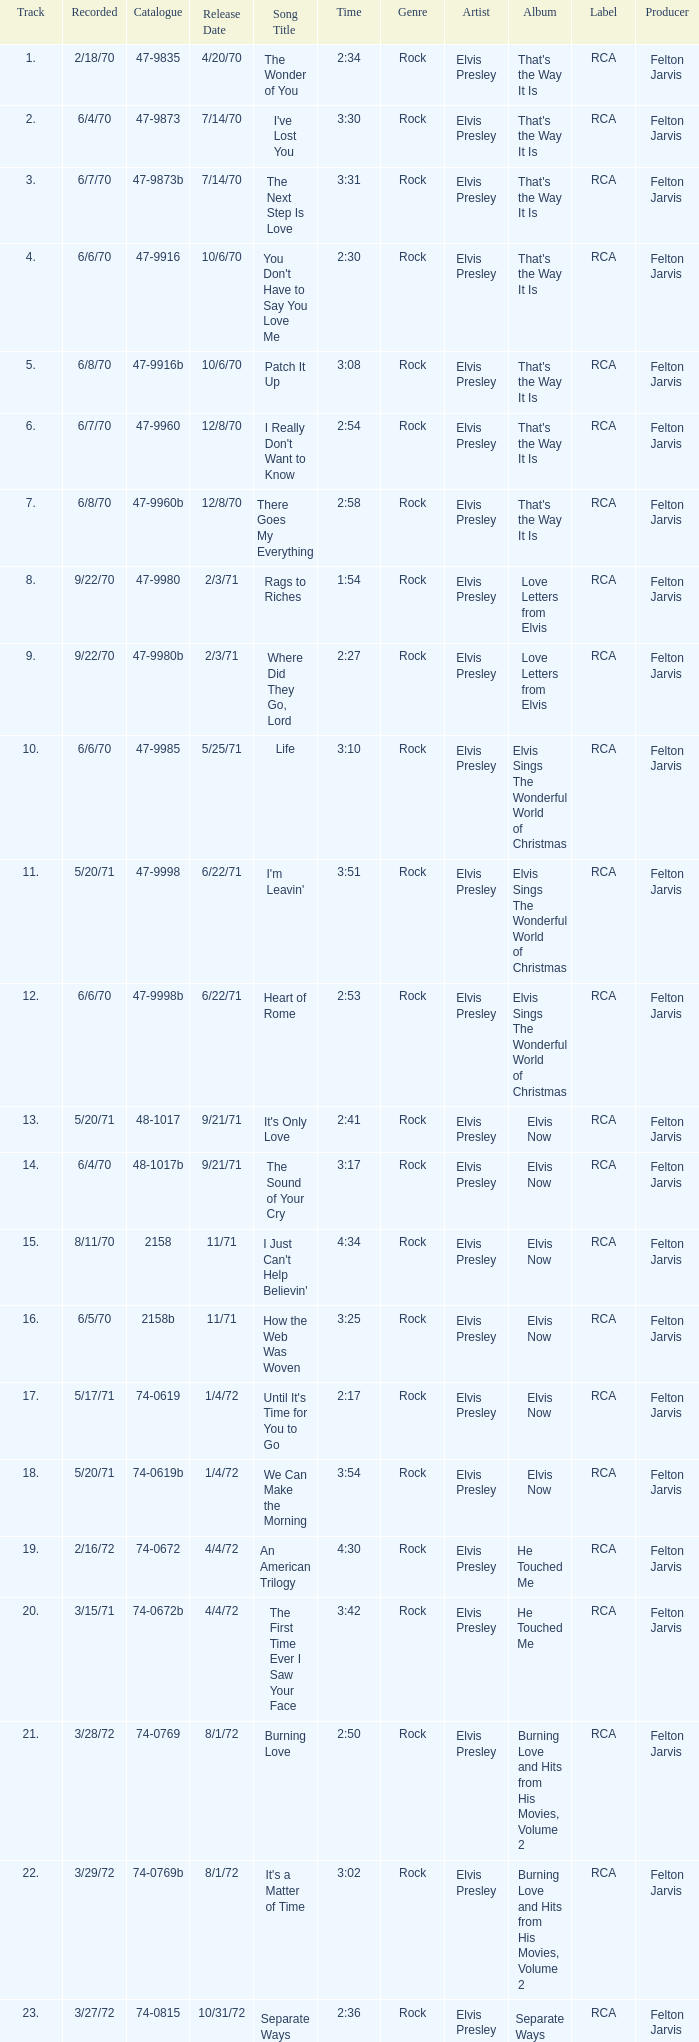What is the highest track for Burning Love? 21.0. 